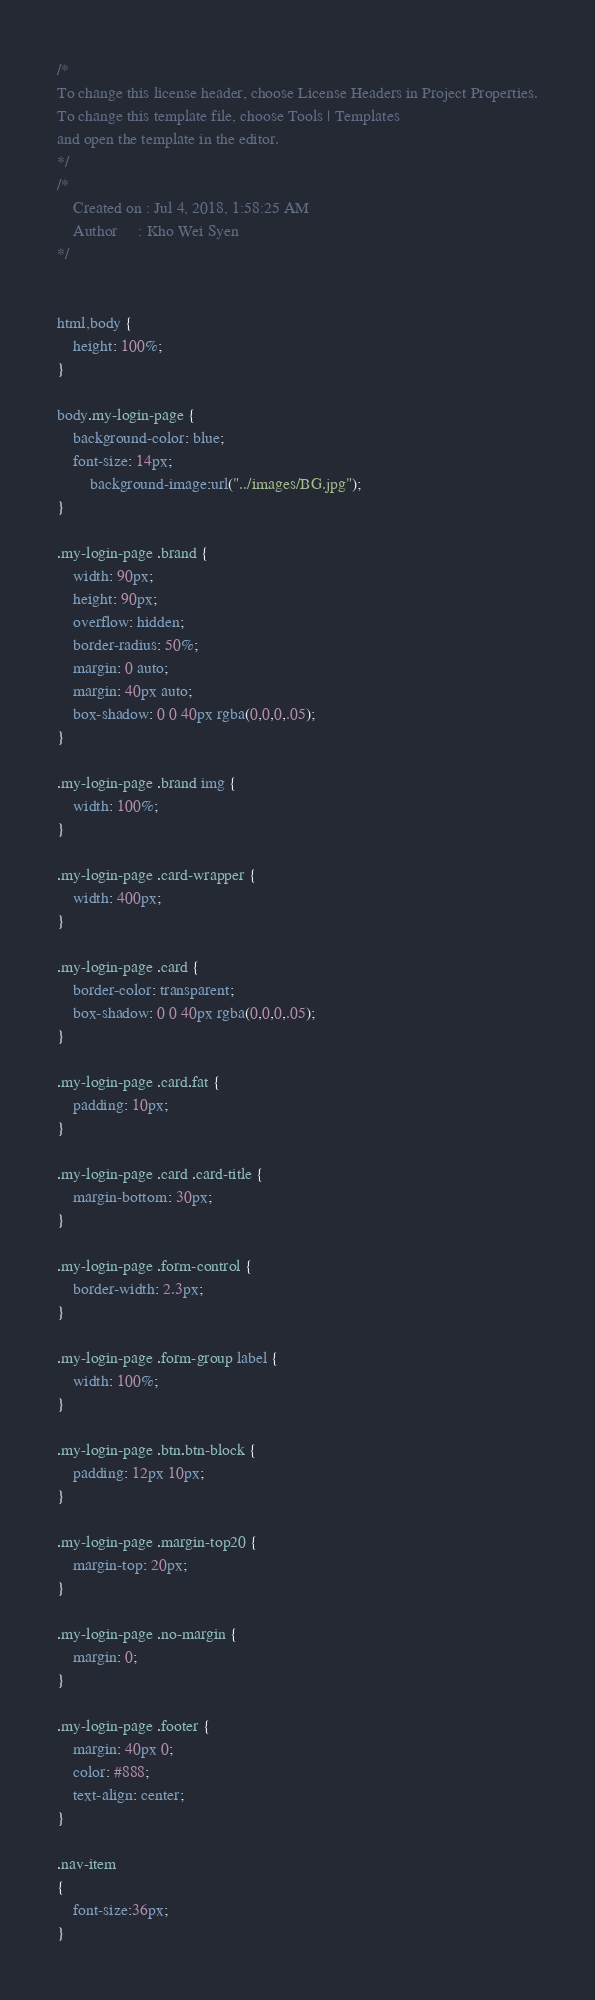Convert code to text. <code><loc_0><loc_0><loc_500><loc_500><_CSS_>/*
To change this license header, choose License Headers in Project Properties.
To change this template file, choose Tools | Templates
and open the template in the editor.
*/
/* 
    Created on : Jul 4, 2018, 1:58:25 AM
    Author     : Kho Wei Syen
*/


html,body {
	height: 100%;
}

body.my-login-page {
	background-color: blue;
	font-size: 14px;
        background-image:url("../images/BG.jpg");
}

.my-login-page .brand {
	width: 90px;
	height: 90px;
	overflow: hidden;
	border-radius: 50%;
	margin: 0 auto;
	margin: 40px auto;
	box-shadow: 0 0 40px rgba(0,0,0,.05);
}

.my-login-page .brand img {
	width: 100%;
}

.my-login-page .card-wrapper {
	width: 400px;
}

.my-login-page .card {
	border-color: transparent;
	box-shadow: 0 0 40px rgba(0,0,0,.05);
}

.my-login-page .card.fat {
	padding: 10px;
}

.my-login-page .card .card-title {
	margin-bottom: 30px;
}

.my-login-page .form-control {
	border-width: 2.3px;
}

.my-login-page .form-group label {
	width: 100%;
}

.my-login-page .btn.btn-block {
	padding: 12px 10px;
}

.my-login-page .margin-top20 {
	margin-top: 20px;
}

.my-login-page .no-margin {
	margin: 0;
}

.my-login-page .footer {
	margin: 40px 0;
	color: #888;
	text-align: center;
}

.nav-item
{
    font-size:36px;
}</code> 